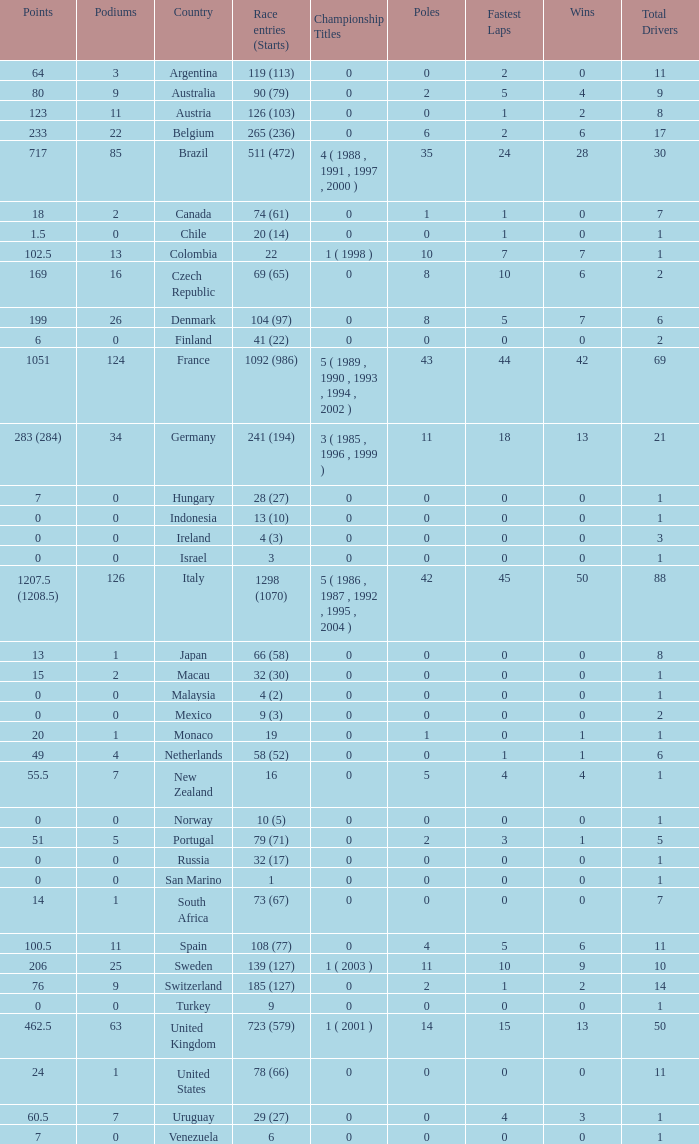How many fastest laps for the nation with 32 (30) entries and starts and fewer than 2 podiums? None. 